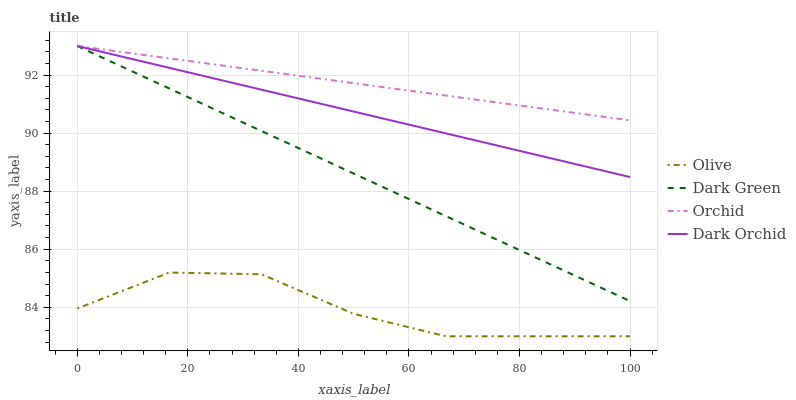Does Olive have the minimum area under the curve?
Answer yes or no. Yes. Does Orchid have the maximum area under the curve?
Answer yes or no. Yes. Does Dark Orchid have the minimum area under the curve?
Answer yes or no. No. Does Dark Orchid have the maximum area under the curve?
Answer yes or no. No. Is Dark Green the smoothest?
Answer yes or no. Yes. Is Olive the roughest?
Answer yes or no. Yes. Is Orchid the smoothest?
Answer yes or no. No. Is Orchid the roughest?
Answer yes or no. No. Does Olive have the lowest value?
Answer yes or no. Yes. Does Dark Orchid have the lowest value?
Answer yes or no. No. Does Dark Green have the highest value?
Answer yes or no. Yes. Is Olive less than Orchid?
Answer yes or no. Yes. Is Dark Orchid greater than Olive?
Answer yes or no. Yes. Does Dark Orchid intersect Orchid?
Answer yes or no. Yes. Is Dark Orchid less than Orchid?
Answer yes or no. No. Is Dark Orchid greater than Orchid?
Answer yes or no. No. Does Olive intersect Orchid?
Answer yes or no. No. 